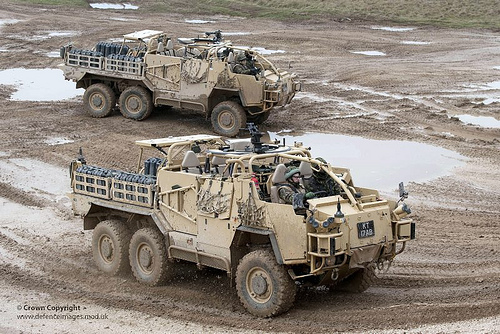<image>
Can you confirm if the truck is behind the water? No. The truck is not behind the water. From this viewpoint, the truck appears to be positioned elsewhere in the scene. 